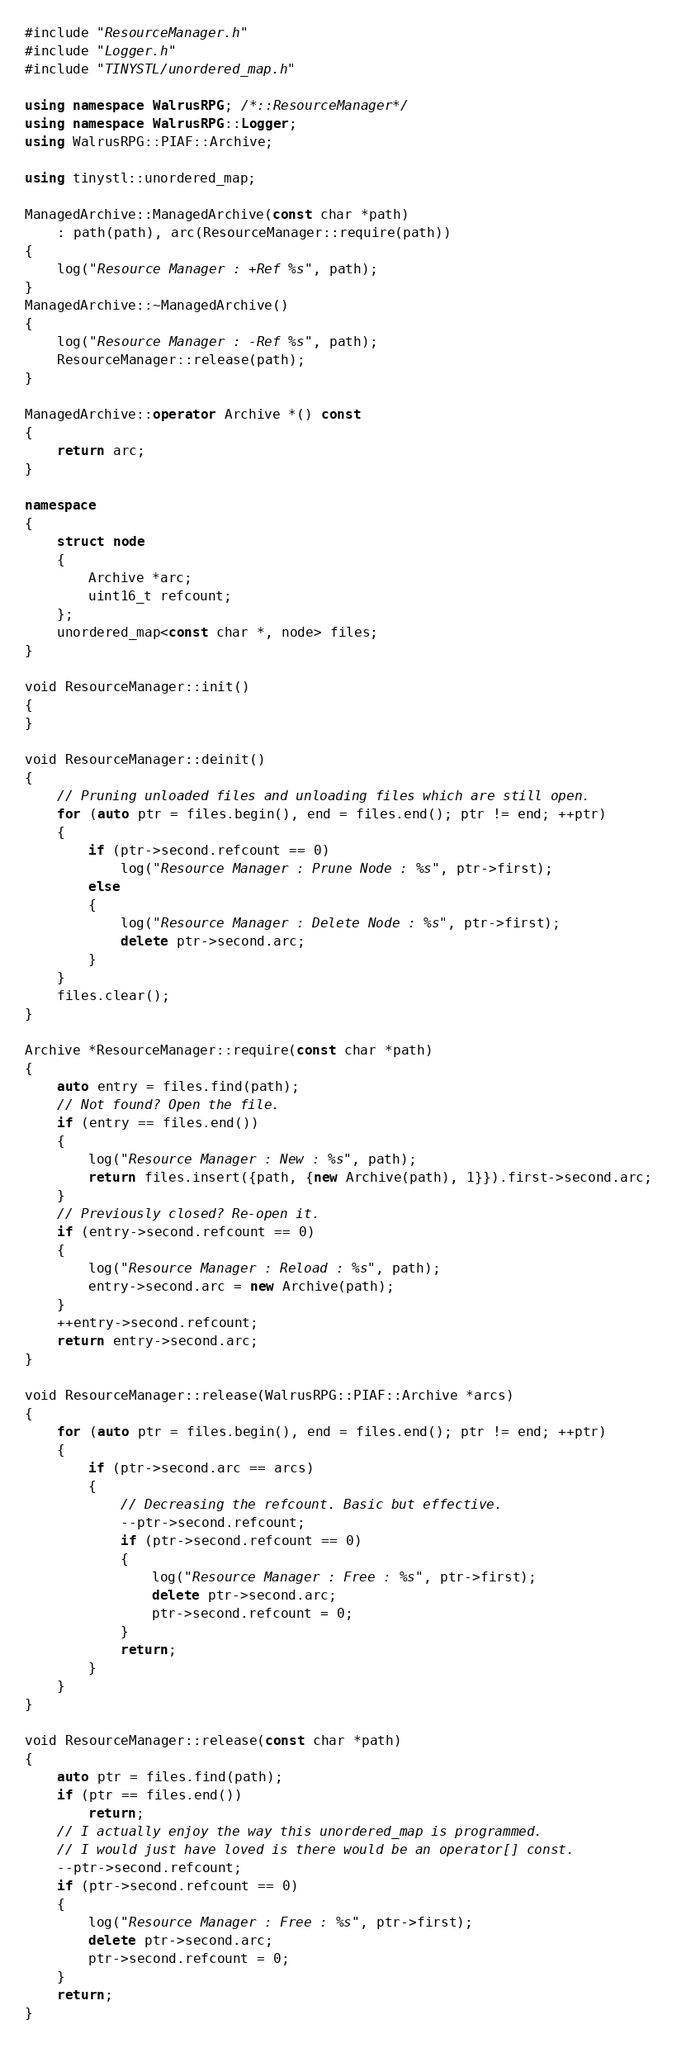<code> <loc_0><loc_0><loc_500><loc_500><_C++_>#include "ResourceManager.h"
#include "Logger.h"
#include "TINYSTL/unordered_map.h"

using namespace WalrusRPG; /*::ResourceManager*/
using namespace WalrusRPG::Logger;
using WalrusRPG::PIAF::Archive;

using tinystl::unordered_map;

ManagedArchive::ManagedArchive(const char *path)
    : path(path), arc(ResourceManager::require(path))
{
    log("Resource Manager : +Ref %s", path);
}
ManagedArchive::~ManagedArchive()
{
    log("Resource Manager : -Ref %s", path);
    ResourceManager::release(path);
}

ManagedArchive::operator Archive *() const
{
    return arc;
}

namespace
{
    struct node
    {
        Archive *arc;
        uint16_t refcount;
    };
    unordered_map<const char *, node> files;
}

void ResourceManager::init()
{
}

void ResourceManager::deinit()
{
    // Pruning unloaded files and unloading files which are still open.
    for (auto ptr = files.begin(), end = files.end(); ptr != end; ++ptr)
    {
        if (ptr->second.refcount == 0)
            log("Resource Manager : Prune Node : %s", ptr->first);
        else
        {
            log("Resource Manager : Delete Node : %s", ptr->first);
            delete ptr->second.arc;
        }
    }
    files.clear();
}

Archive *ResourceManager::require(const char *path)
{
    auto entry = files.find(path);
    // Not found? Open the file.
    if (entry == files.end())
    {
        log("Resource Manager : New : %s", path);
        return files.insert({path, {new Archive(path), 1}}).first->second.arc;
    }
    // Previously closed? Re-open it.
    if (entry->second.refcount == 0)
    {
        log("Resource Manager : Reload : %s", path);
        entry->second.arc = new Archive(path);
    }
    ++entry->second.refcount;
    return entry->second.arc;
}

void ResourceManager::release(WalrusRPG::PIAF::Archive *arcs)
{
    for (auto ptr = files.begin(), end = files.end(); ptr != end; ++ptr)
    {
        if (ptr->second.arc == arcs)
        {
            // Decreasing the refcount. Basic but effective.
            --ptr->second.refcount;
            if (ptr->second.refcount == 0)
            {
                log("Resource Manager : Free : %s", ptr->first);
                delete ptr->second.arc;
                ptr->second.refcount = 0;
            }
            return;
        }
    }
}

void ResourceManager::release(const char *path)
{
    auto ptr = files.find(path);
    if (ptr == files.end())
        return;
    // I actually enjoy the way this unordered_map is programmed.
    // I would just have loved is there would be an operator[] const.
    --ptr->second.refcount;
    if (ptr->second.refcount == 0)
    {
        log("Resource Manager : Free : %s", ptr->first);
        delete ptr->second.arc;
        ptr->second.refcount = 0;
    }
    return;
}
</code> 